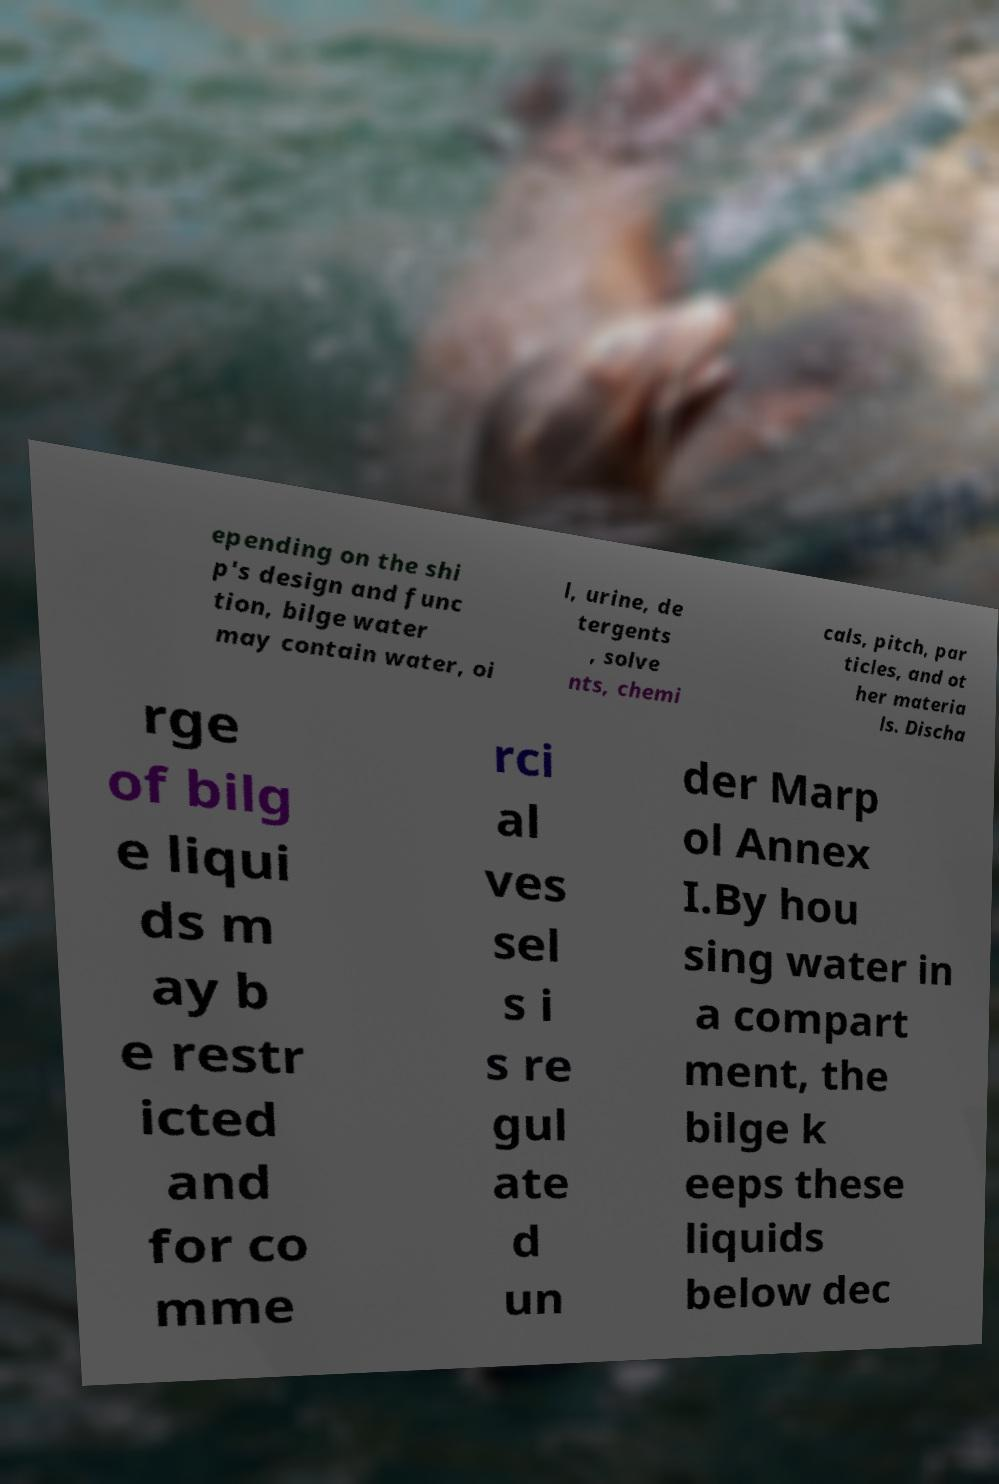Please identify and transcribe the text found in this image. epending on the shi p's design and func tion, bilge water may contain water, oi l, urine, de tergents , solve nts, chemi cals, pitch, par ticles, and ot her materia ls. Discha rge of bilg e liqui ds m ay b e restr icted and for co mme rci al ves sel s i s re gul ate d un der Marp ol Annex I.By hou sing water in a compart ment, the bilge k eeps these liquids below dec 